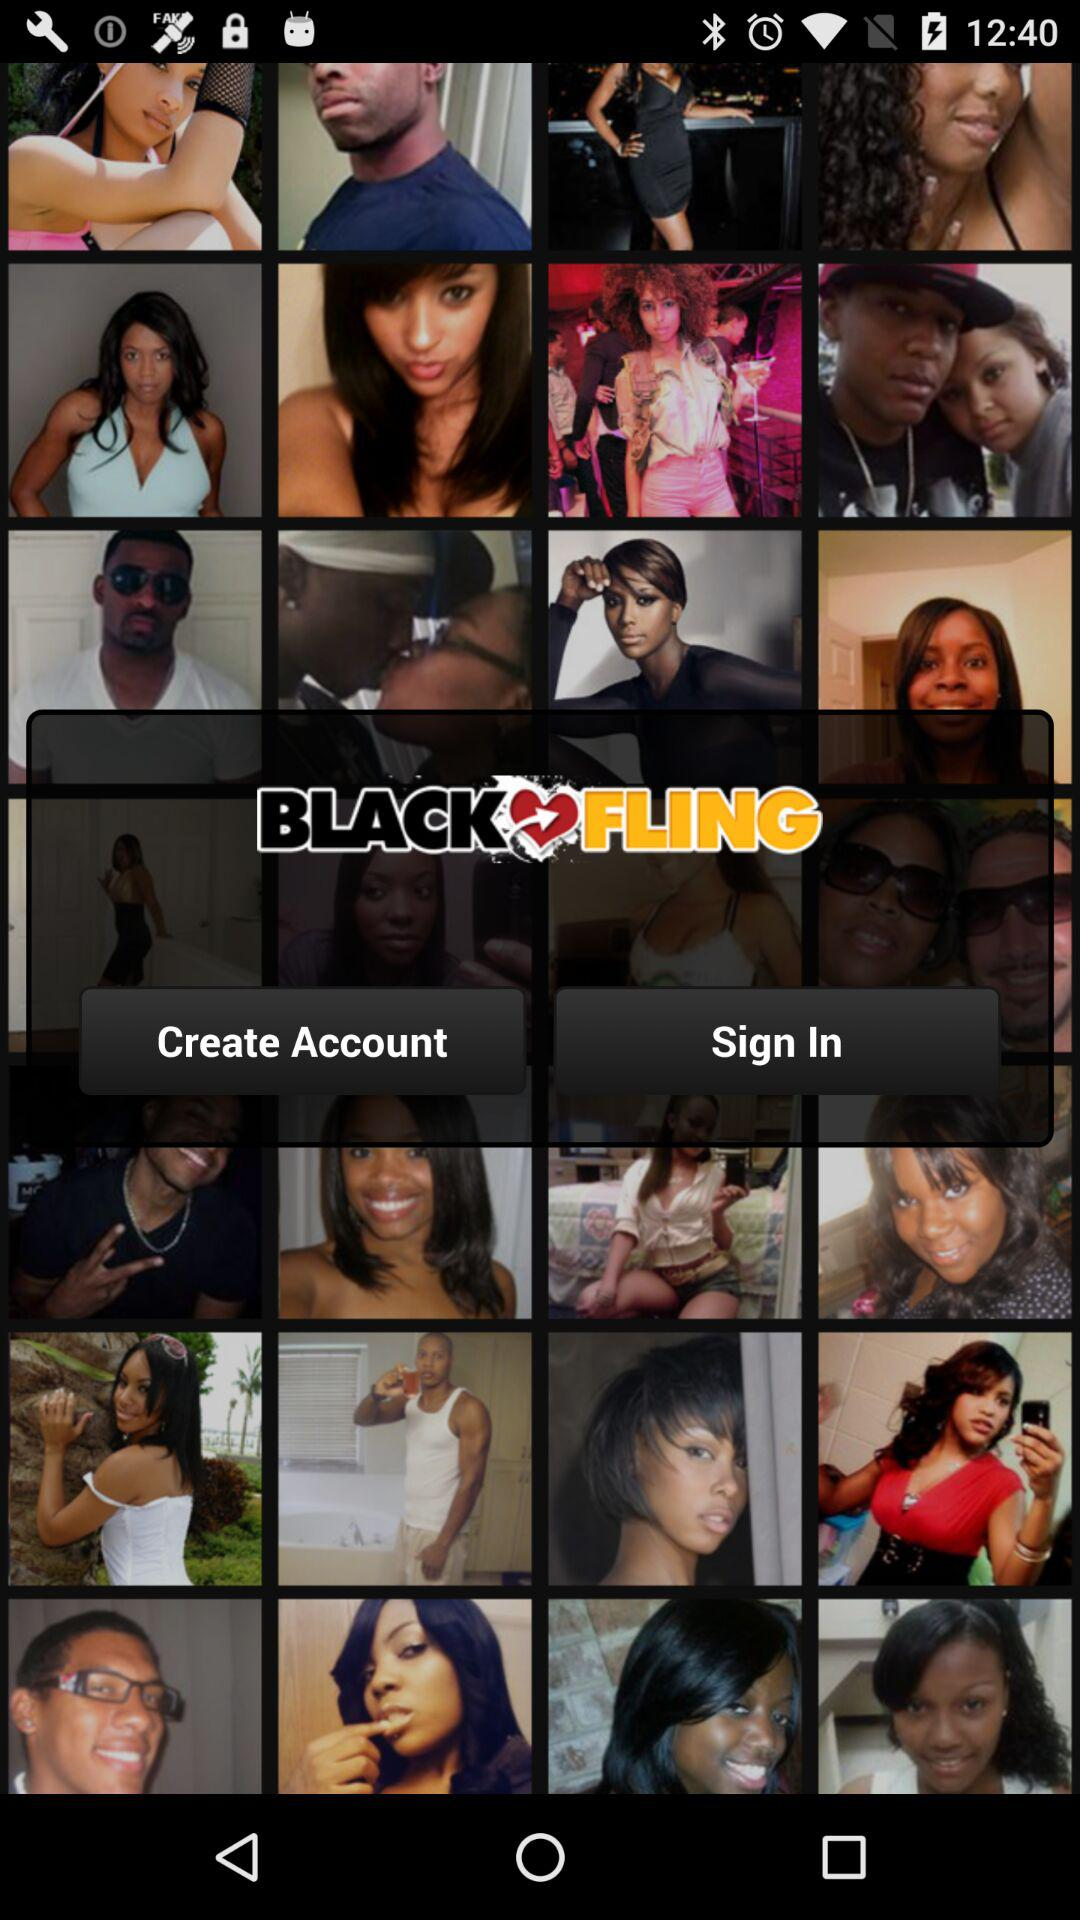What is the name of the application? The name of the application is "BLACKFLING". 